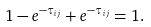<formula> <loc_0><loc_0><loc_500><loc_500>1 - e ^ { - \tau _ { i j } } + e ^ { - \tau _ { i j } } = 1 .</formula> 